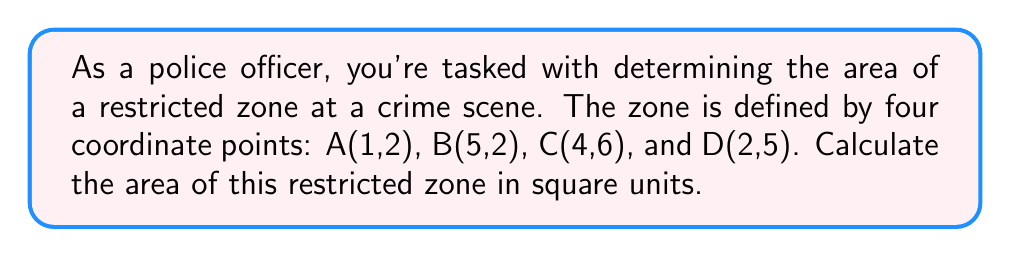Give your solution to this math problem. To solve this problem, we'll use the Shoelace formula (also known as the surveyor's formula) to calculate the area of the irregular quadrilateral formed by the given points. The steps are as follows:

1. List the coordinates in order (either clockwise or counterclockwise), repeating the first point at the end:
   $(x_1, y_1), (x_2, y_2), (x_3, y_3), (x_4, y_4), (x_1, y_1)$

2. Apply the Shoelace formula:
   $$\text{Area} = \frac{1}{2}|(x_1y_2 + x_2y_3 + x_3y_4 + x_4y_1) - (y_1x_2 + y_2x_3 + y_3x_4 + y_4x_1)|$$

3. Substitute the given coordinates:
   A(1,2), B(5,2), C(4,6), D(2,5), A(1,2)

4. Calculate:
   $$\begin{align}
   \text{Area} &= \frac{1}{2}|(1 \cdot 2 + 5 \cdot 6 + 4 \cdot 5 + 2 \cdot 2) - (2 \cdot 5 + 2 \cdot 4 + 6 \cdot 2 + 5 \cdot 1)|\\
   &= \frac{1}{2}|(2 + 30 + 20 + 4) - (10 + 8 + 12 + 5)|\\
   &= \frac{1}{2}|56 - 35|\\
   &= \frac{1}{2} \cdot 21\\
   &= 10.5
   \end{align}$$

Therefore, the area of the restricted zone is 10.5 square units.
Answer: 10.5 square units 